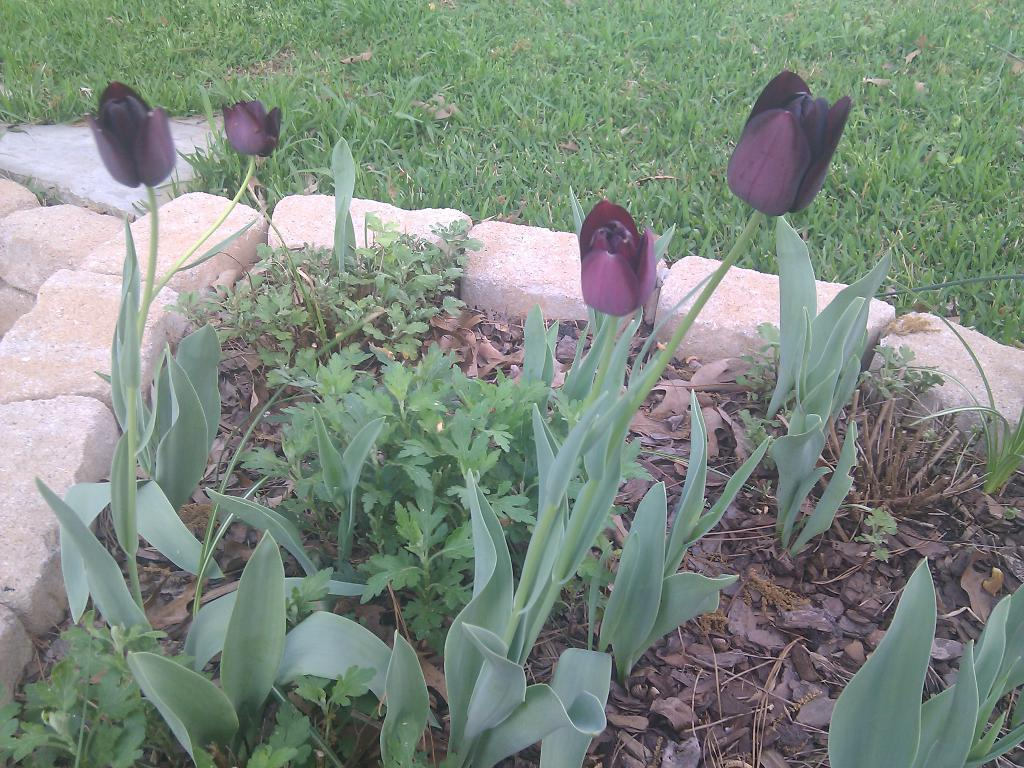What type of living organisms are present in the image? The image contains plants. What specific feature can be observed on the plants? The plants have flowers. What type of vegetation is at the bottom of the image? There is grass at the bottom of the image. What type of natural objects are surrounding the plants? There are rocks around the plants. What level of difficulty is the beginner's request in the image? There is no request or difficulty level present in the image; it features plants, flowers, grass, and rocks. 